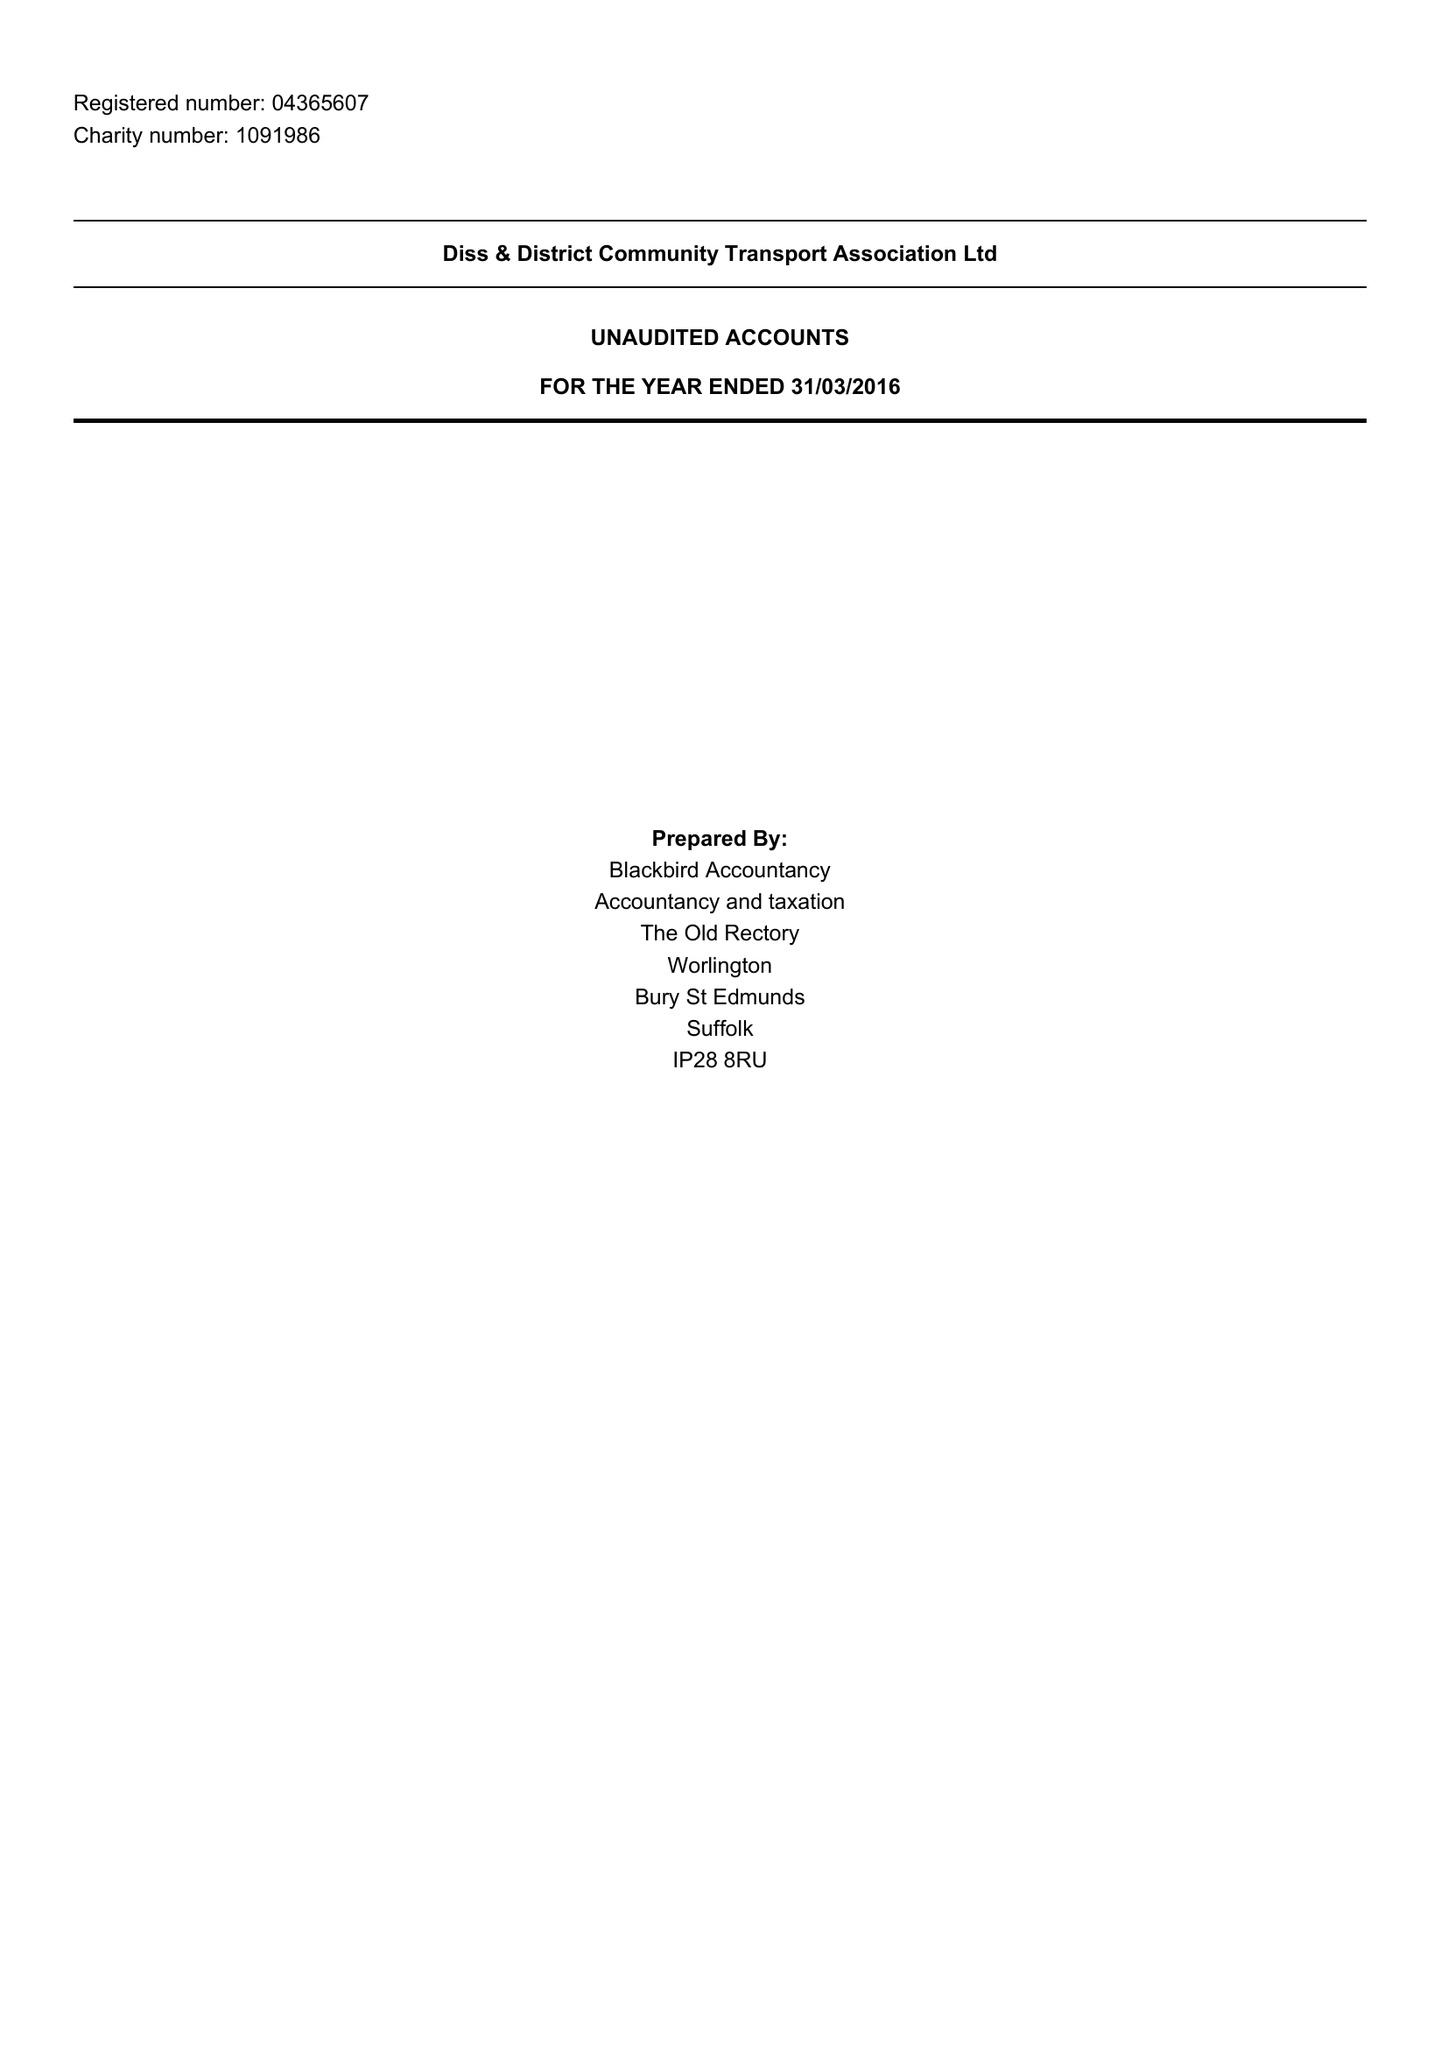What is the value for the spending_annually_in_british_pounds?
Answer the question using a single word or phrase. 297962.00 